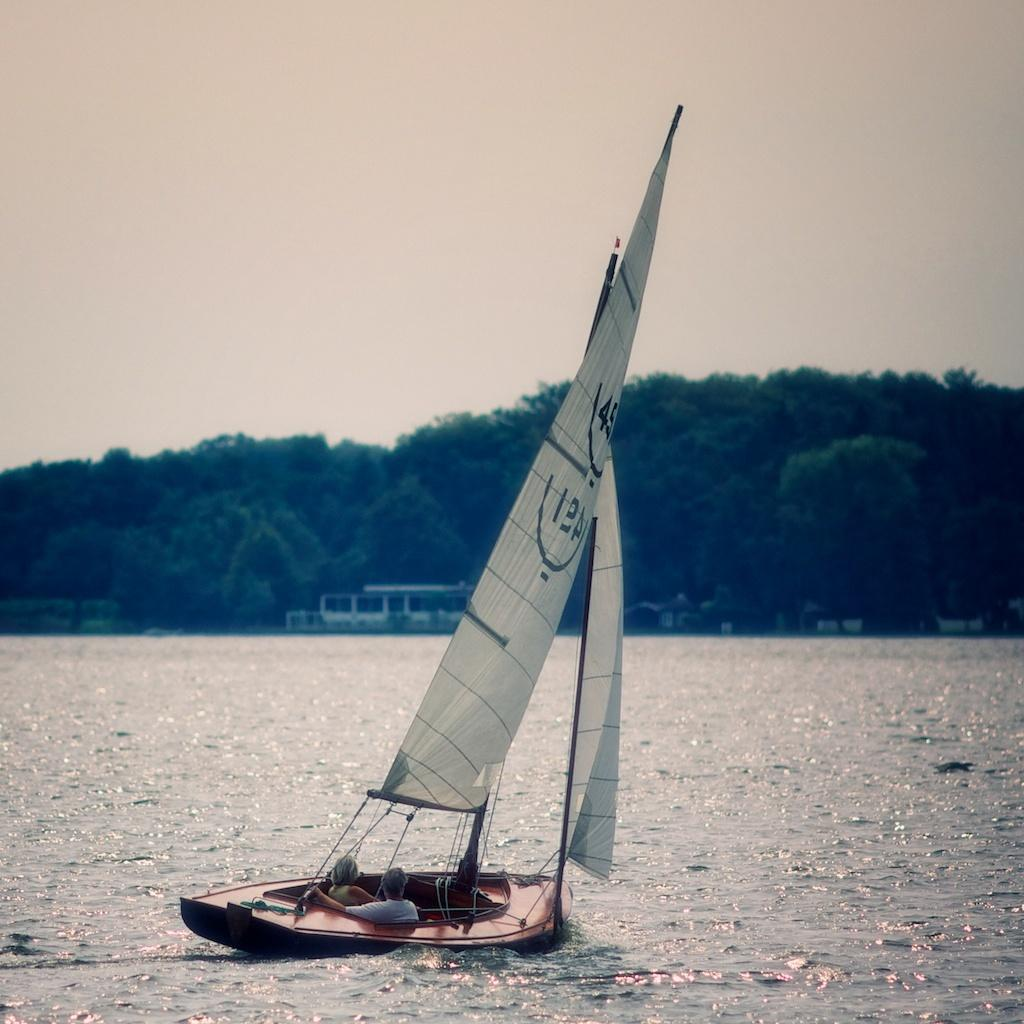How many people are in the image? There are two persons in the image. What are the persons doing in the image? The persons are sitting in a sailboat. Where is the sailboat located? The sailboat is placed in water. What can be seen in the background of the image? There is a building, a group of trees, and the sky visible in the background of the image. What type of jail can be seen in the image? There is no jail present in the image. How does the sailboat reach its end in the image? The image does not depict the sailboat reaching its end; it only shows the persons sitting in the sailboat. 